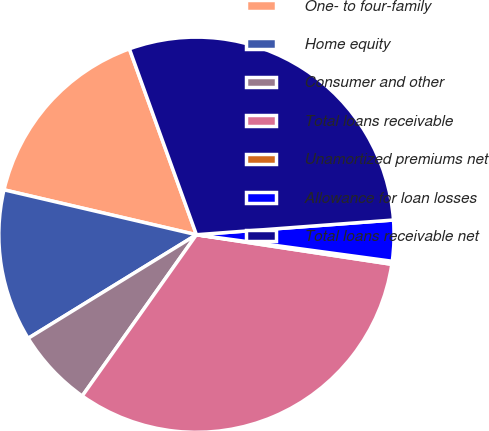Convert chart to OTSL. <chart><loc_0><loc_0><loc_500><loc_500><pie_chart><fcel>One- to four-family<fcel>Home equity<fcel>Consumer and other<fcel>Total loans receivable<fcel>Unamortized premiums net<fcel>Allowance for loan losses<fcel>Total loans receivable net<nl><fcel>15.84%<fcel>12.43%<fcel>6.41%<fcel>32.41%<fcel>0.25%<fcel>3.33%<fcel>29.32%<nl></chart> 